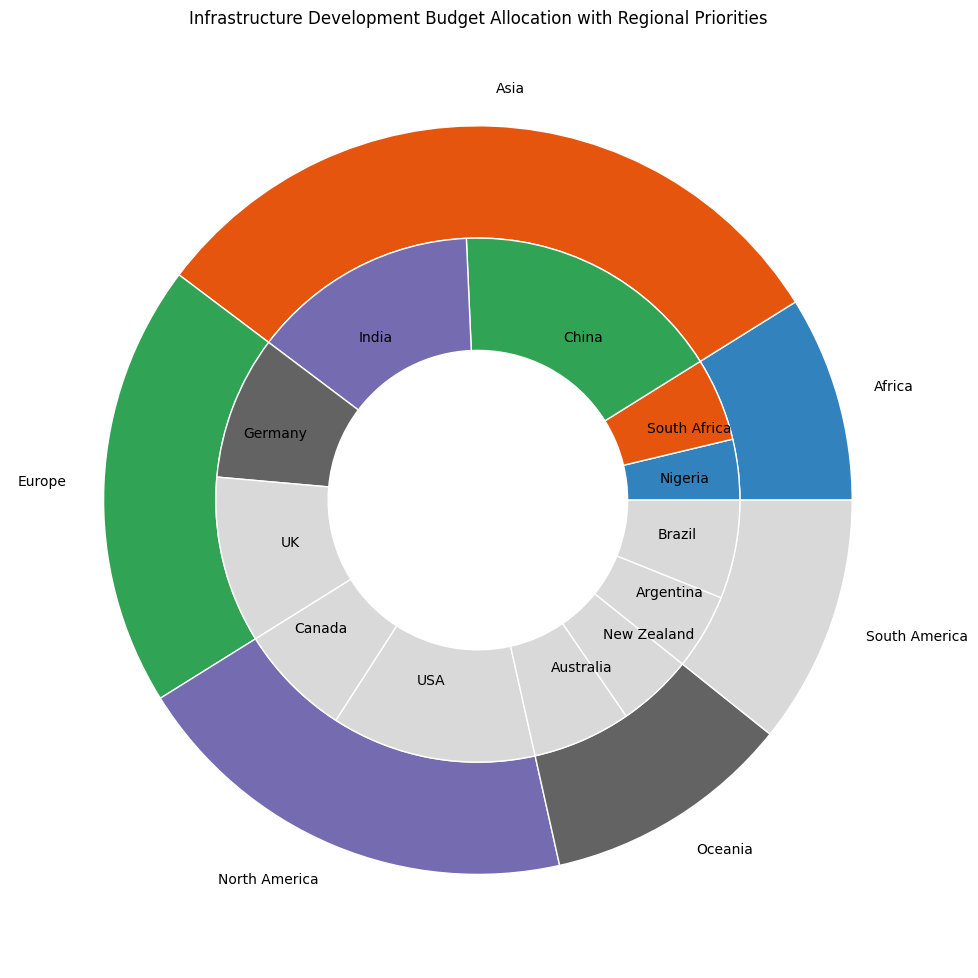Which region has the largest infrastructure development budget allocation? Look at the outer pie chart where regions are labeled, and identify the region with the largest section.
Answer: Asia Among the sub-regions in North America, which one has the smallest budget allocation? Look at the sections in the inner pie chart for North America and find the smallest section labeled with a sub-region.
Answer: Canada (Railways) What is the combined budget allocation for Roads in Asia? Find the inner pie sections labeled as 'Roads' within the Asia region, and sum their budget values (China: 15000000 + India: 13000000) = 28000000.
Answer: 28000000 How does the budget allocation for Airports in North America compare to Airports in Europe? Identify the inner pie sections labeled 'Airports' in both North America and Europe and compare their sizes (North America: 7000000; Europe: 5000000).
Answer: Greater in North America Calculate the average budget allocation across all sub-regions in Oceania. Sum the budgets allocated to all sub-regions in Oceania and divide by the number of sub-regions ((Australia: Roads: 8000000 + Railways: 5000000) + (New Zealand: Roads: 6000000 + Ports: 4000000))/4 = (13000000 + 10000000)/4 = 23000000/4).
Answer: 5750000 Which sub-region in the Europe region has the highest budget allocation for Railways? Look at the Railways sections within the Europe region's inner pie and find the one with the highest value (Germany: 8000000).
Answer: Germany By how much is the Roads budget in China greater than the Roads budget in the USA? Subtract the budget allocated to Roads in the USA from the budget allocated to Roads in China (15000000 - 12000000).
Answer: 3000000 Identify the color representation for the South American region in the pie chart. Find the section color of the South American region in the outer pie chart.
Answer: Yellow Is the budget allocation for Ports in India greater than the combined Ports budget in Argentina and New Zealand? Compare the budget for Ports in India with the sum of the Ports budgets in Argentina and New Zealand (7000000 > (4000000 + 4000000) = 8000000).
Answer: No 